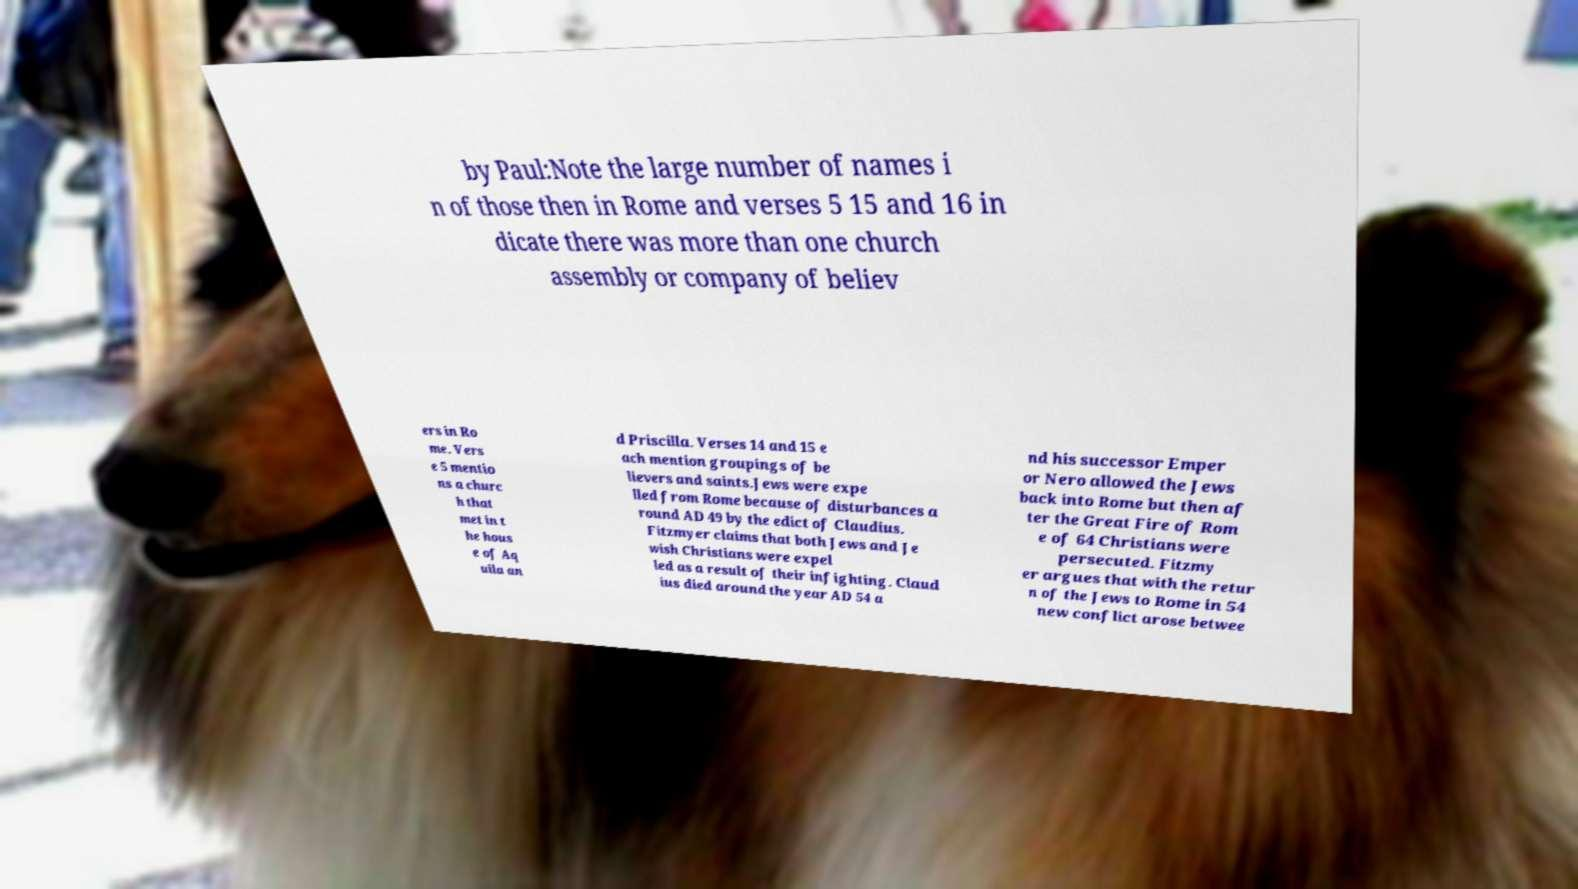Please identify and transcribe the text found in this image. by Paul:Note the large number of names i n of those then in Rome and verses 5 15 and 16 in dicate there was more than one church assembly or company of believ ers in Ro me. Vers e 5 mentio ns a churc h that met in t he hous e of Aq uila an d Priscilla. Verses 14 and 15 e ach mention groupings of be lievers and saints.Jews were expe lled from Rome because of disturbances a round AD 49 by the edict of Claudius. Fitzmyer claims that both Jews and Je wish Christians were expel led as a result of their infighting. Claud ius died around the year AD 54 a nd his successor Emper or Nero allowed the Jews back into Rome but then af ter the Great Fire of Rom e of 64 Christians were persecuted. Fitzmy er argues that with the retur n of the Jews to Rome in 54 new conflict arose betwee 